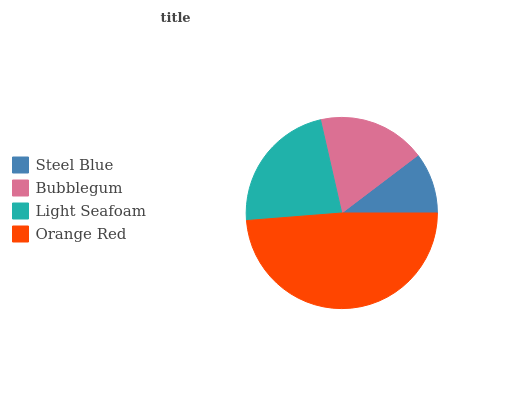Is Steel Blue the minimum?
Answer yes or no. Yes. Is Orange Red the maximum?
Answer yes or no. Yes. Is Bubblegum the minimum?
Answer yes or no. No. Is Bubblegum the maximum?
Answer yes or no. No. Is Bubblegum greater than Steel Blue?
Answer yes or no. Yes. Is Steel Blue less than Bubblegum?
Answer yes or no. Yes. Is Steel Blue greater than Bubblegum?
Answer yes or no. No. Is Bubblegum less than Steel Blue?
Answer yes or no. No. Is Light Seafoam the high median?
Answer yes or no. Yes. Is Bubblegum the low median?
Answer yes or no. Yes. Is Steel Blue the high median?
Answer yes or no. No. Is Steel Blue the low median?
Answer yes or no. No. 